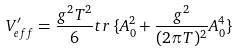<formula> <loc_0><loc_0><loc_500><loc_500>V _ { e f f } ^ { \prime } = \frac { g ^ { 2 } T ^ { 2 } } { 6 } t r \, \{ A _ { 0 } ^ { 2 } + \frac { g ^ { 2 } } { ( 2 \pi T ) ^ { 2 } } A _ { 0 } ^ { 4 } \}</formula> 